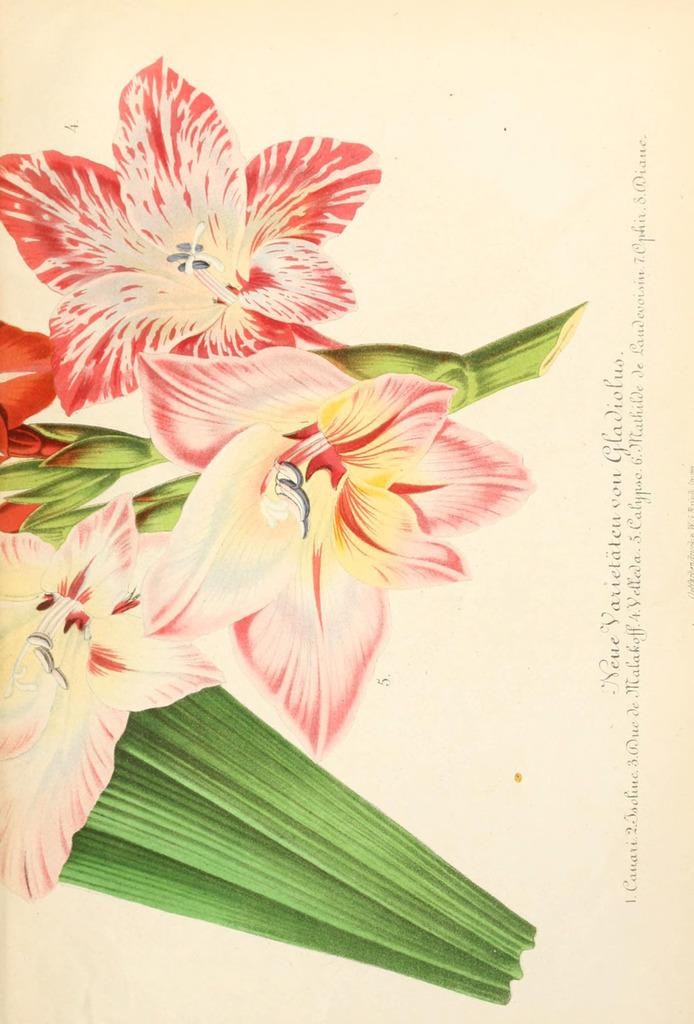What colors are the flowers in the image? The flowers in the image are red and white. What color are the leaves of the flowers? The leaves of the flowers are green. What is the color of the paper on which the image is printed? The image is on a cream-colored paper. Where is the text located in the image? The text is written on the right side of the image. Can you tell me how many rats are hiding behind the flowers in the image? There are no rats present in the image; it features only flowers and leaves. What type of bulb is used to illuminate the flowers in the image? The image does not depict any lighting or bulbs; it is a still image of flowers and leaves. 